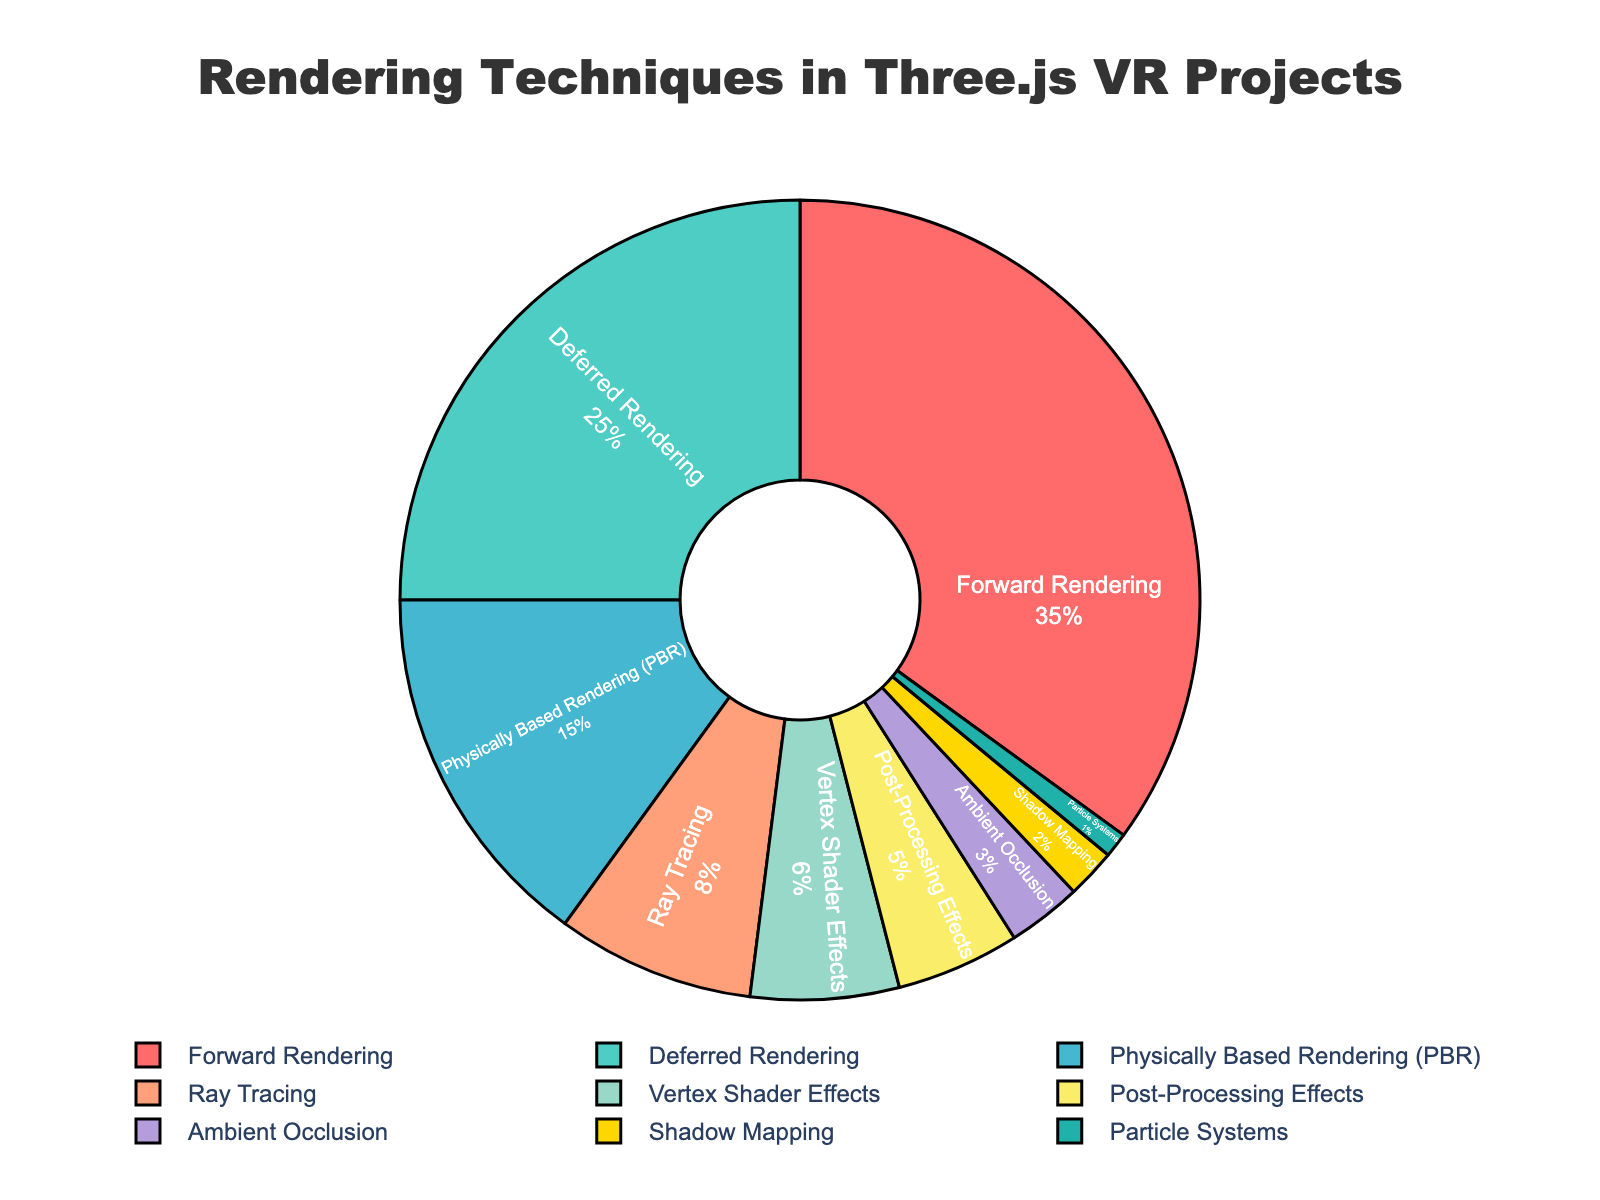What percentage of projects use Forward Rendering? Locate the "Forward Rendering" section in the pie chart, which is marked in a specific color. The percentage is given as 35%.
Answer: 35% Which rendering technique is utilized the least? Identify the smallest segment in the pie chart. The smallest section corresponds to the "Particle Systems" technique.
Answer: Particle Systems Is Deferred Rendering more common than Physically Based Rendering (PBR)? Compare the sizes of the segments for "Deferred Rendering" and "Physically Based Rendering (PBR)". Deferred Rendering has 25%, and Physically Based Rendering (PBR) has 15%.
Answer: Yes What is the combined percentage of projects that use Vertex Shader Effects and Post-Processing Effects? Locate and sum the percentages for "Vertex Shader Effects" (6%) and "Post-Processing Effects" (5%). The combined total is 6% + 5% = 11%.
Answer: 11% Which technique has the second highest usage percentage? Identify the segment with the second largest size. "Forward Rendering" is the largest at 35%, followed by "Deferred Rendering" at 25%.
Answer: Deferred Rendering Are more projects using Ray Tracing or Ambient Occlusion? Compare the segments for "Ray Tracing" and "Ambient Occlusion". Ray Tracing has 8%, whereas Ambient Occlusion has 3%.
Answer: Ray Tracing What percentage of projects use techniques other than Forward Rendering and Deferred Rendering? Subtract the combined percentage of Forward Rendering (35%) and Deferred Rendering (25%) from 100%. 100% - 35% - 25% = 40%.
Answer: 40% By what percentage does Physically Based Rendering (PBR) exceed Particle Systems? Subtract the percentage of Particle Systems (1%) from the percentage of Physically Based Rendering (PBR) (15%). 15% - 1% = 14%.
Answer: 14% What is the total percentage of projects using techniques that individually account for less than 10% of the total? Add the percentages for Ray Tracing (8%), Vertex Shader Effects (6%), Post-Processing Effects (5%), Ambient Occlusion (3%), Shadow Mapping (2%), and Particle Systems (1%). 8% + 6% + 5% + 3% + 2% + 1% = 25%.
Answer: 25% What is the visual attribute for the segment representing Shadow Mapping? Locate the section in the pie chart labeled "Shadow Mapping". Without the specific visual, describe its distinct attributes like color and line outlining observed in the chart code. It would likely have one of the unique colors assigned and a clear line delineation.
Answer: Unique color and line delineation 